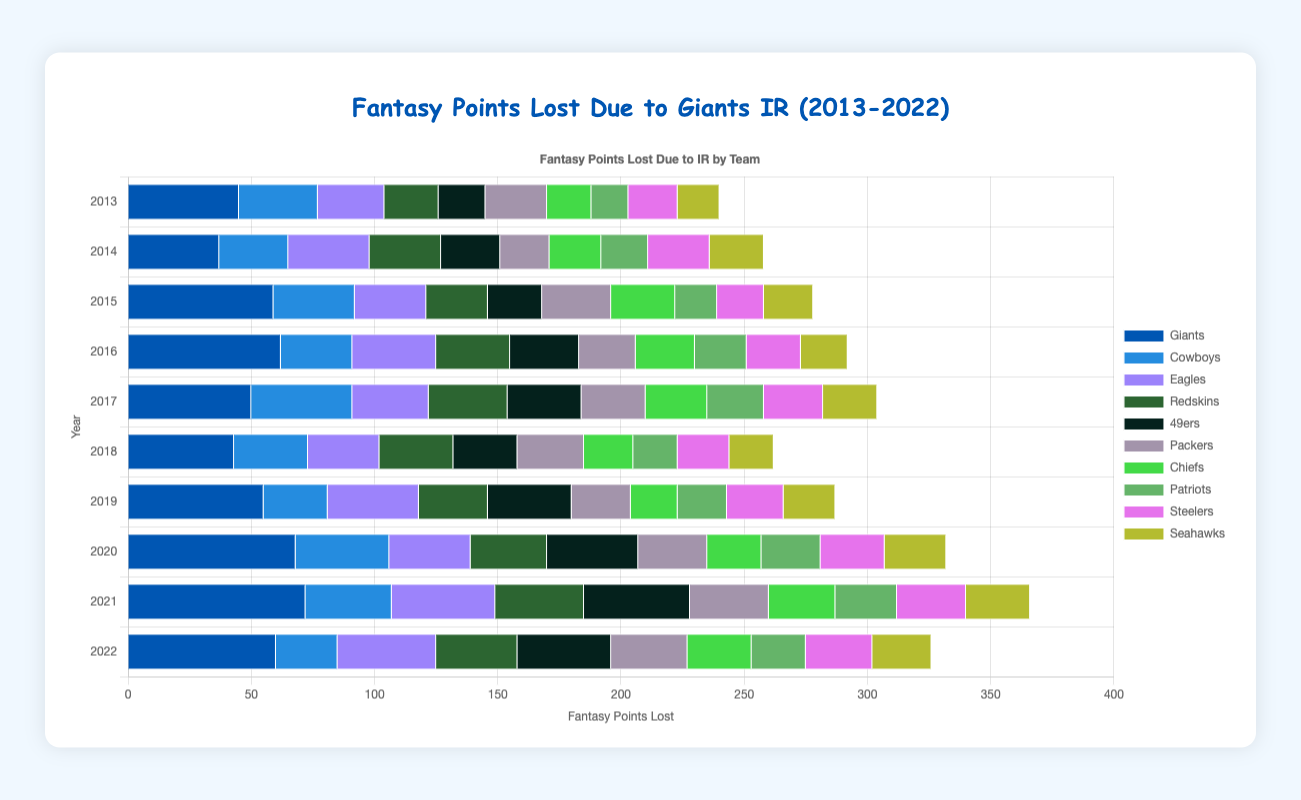Which team had the highest points lost due to IR in 2021? From the bar chart in 2021, the Giants have the highest points lost due to IR.
Answer: Giants How did the Giants' points lost in 2015 compare to their points lost in 2017? In 2015, the Giants lost 59 points, while in 2017, they lost 50 points. Therefore, they lost more points in 2015 compared to 2017 by a difference of 9 points.
Answer: The Giants lost 9 more points in 2015 Across the entire decade, which year did the Giants have the lowest points lost and how many points were lost that year? Observing the chart, in 2014, the Giants have the lowest points lost at 37 points.
Answer: 2014, 37 points Considering the years 2013, 2017, and 2021, in which year did the Cowboys have the most points lost due to IR? In the years 2013, 2017, and 2021, the points lost by Cowboys due to IR were 32, 41, and 35 respectively. They lost the most points in 2017.
Answer: 2017 In comparison to the Giants, did the Patriots ever surpass the Giants in points lost due to IR in any year from 2013 to 2022? By comparing the yearly points lost by both teams, the Patriots never surpass the Giants in points lost due to IR in the span from 2013 to 2022.
Answer: No What is the average points lost due to IR for the Steelers from 2013 to 2022? Summing up the points lost by the Steelers from 2013 to 2022: 20 + 25 + 19 + 22 + 24 + 21 + 23 + 26 + 28 + 27 = 235. There are 10 years, so the average is 235/10 = 23.5.
Answer: 23.5 Between 2018 and 2020, which team had the most notable increase in points lost due to IR? Calculating the difference for each team between 2018 and 2020. The Giants had the largest increase: 68 - 43 = 25 points.
Answer: Giants In 2020, which team had the least points lost due to IR, and how much was it? By viewing the bar chart for 2020, the Patriots had the least points lost due to IR at 24 points.
Answer: Patriots, 24 Which team consistently had the lowest variation in points lost due to IR throughout the decade? Assessing the data, the team with consistently low variation in points lost are the Chiefs, ranging from 18 to 27 points.
Answer: Chiefs 